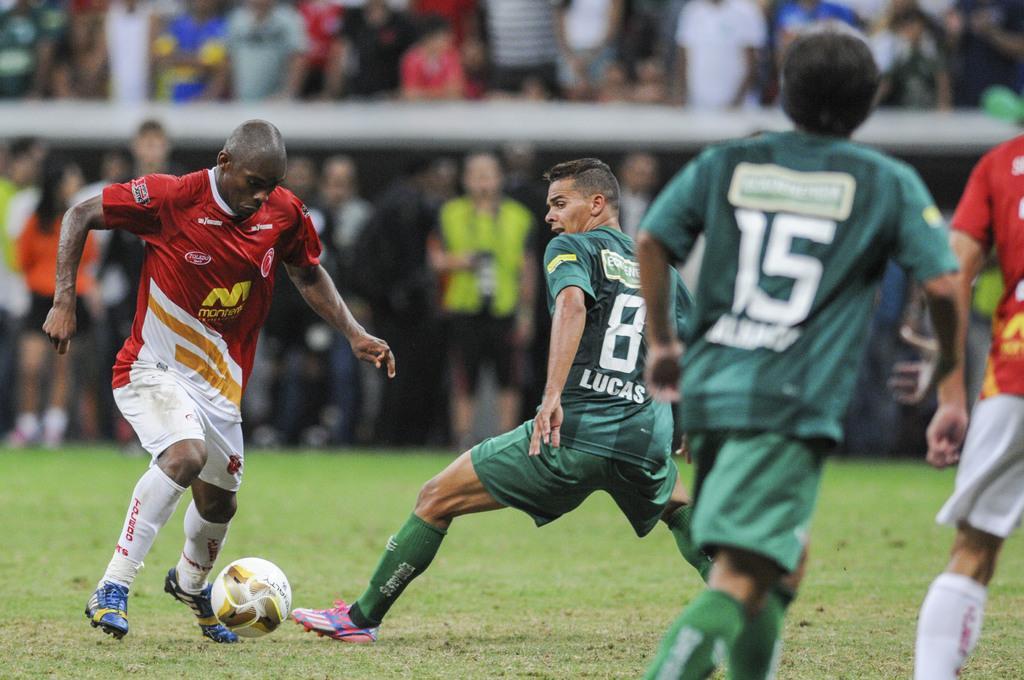Could you give a brief overview of what you see in this image? In the image we can see there are players wearing, clothes, socks and shoes, they are playing on the ground. Here we can see a ball, grass and the background is blurred. 